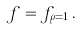<formula> <loc_0><loc_0><loc_500><loc_500>f = f _ { \rho = 1 } \, .</formula> 